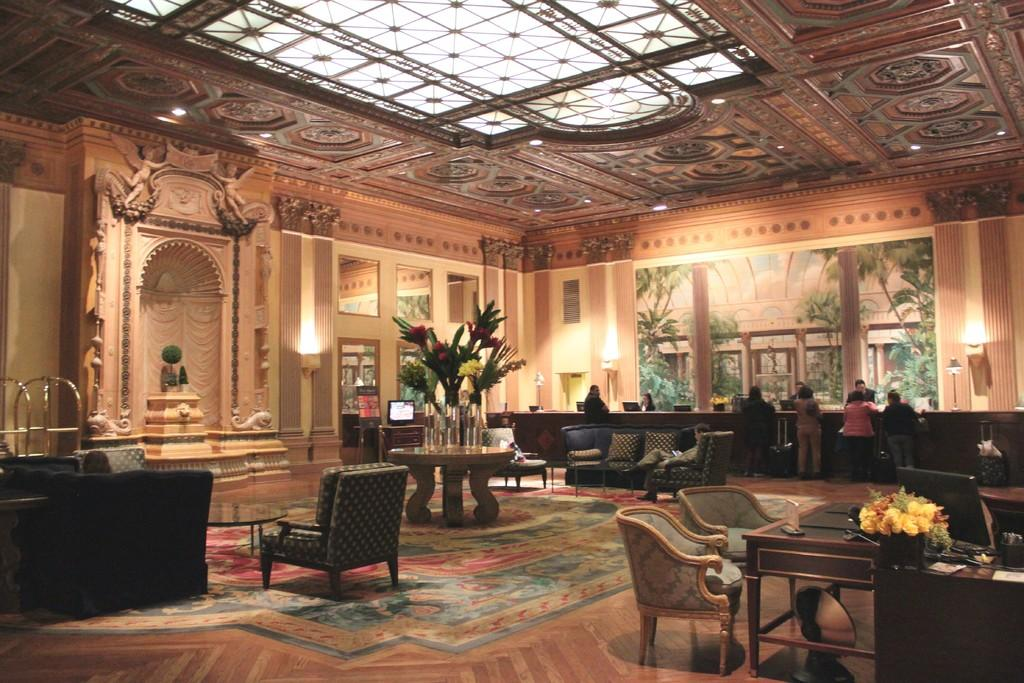What type of furniture is present in the image? There are sofas and chairs in the image. Can you describe the people in the image? There are people standing in the background of the image. What decorative elements can be seen in the image? There are flowers visible in the image. What is used for illumination in the image? There are lights in the image. How many eggs are hanging from the lights in the image? There are no eggs present in the image, and they are not hanging from the lights. 